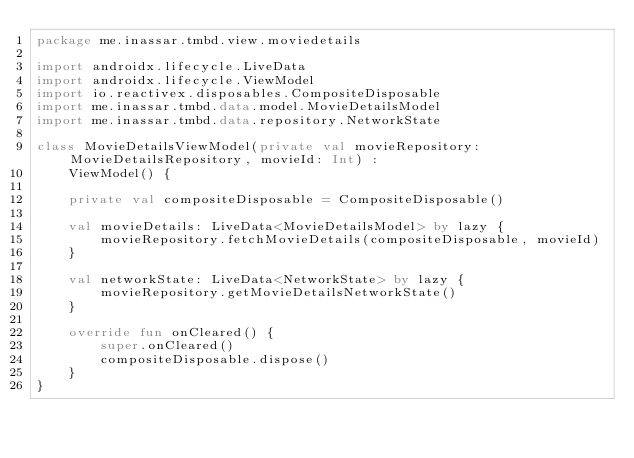<code> <loc_0><loc_0><loc_500><loc_500><_Kotlin_>package me.inassar.tmbd.view.moviedetails

import androidx.lifecycle.LiveData
import androidx.lifecycle.ViewModel
import io.reactivex.disposables.CompositeDisposable
import me.inassar.tmbd.data.model.MovieDetailsModel
import me.inassar.tmbd.data.repository.NetworkState

class MovieDetailsViewModel(private val movieRepository: MovieDetailsRepository, movieId: Int) :
    ViewModel() {

    private val compositeDisposable = CompositeDisposable()

    val movieDetails: LiveData<MovieDetailsModel> by lazy {
        movieRepository.fetchMovieDetails(compositeDisposable, movieId)
    }

    val networkState: LiveData<NetworkState> by lazy {
        movieRepository.getMovieDetailsNetworkState()
    }

    override fun onCleared() {
        super.onCleared()
        compositeDisposable.dispose()
    }
}</code> 